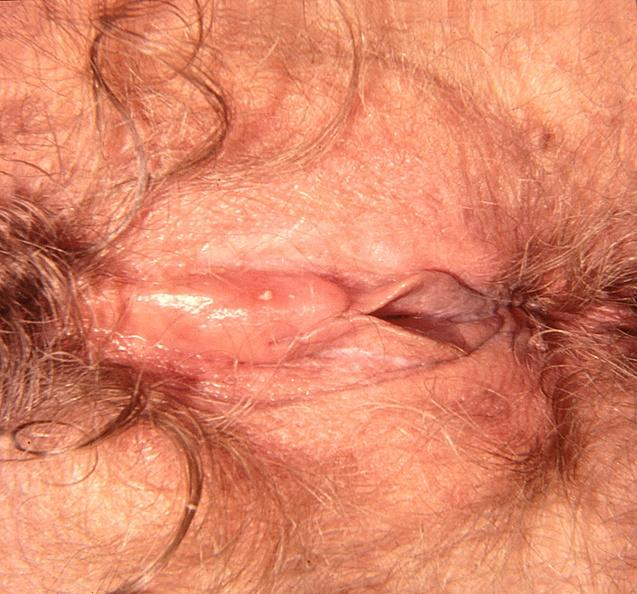where does this part belong to?
Answer the question using a single word or phrase. Female reproductive system 